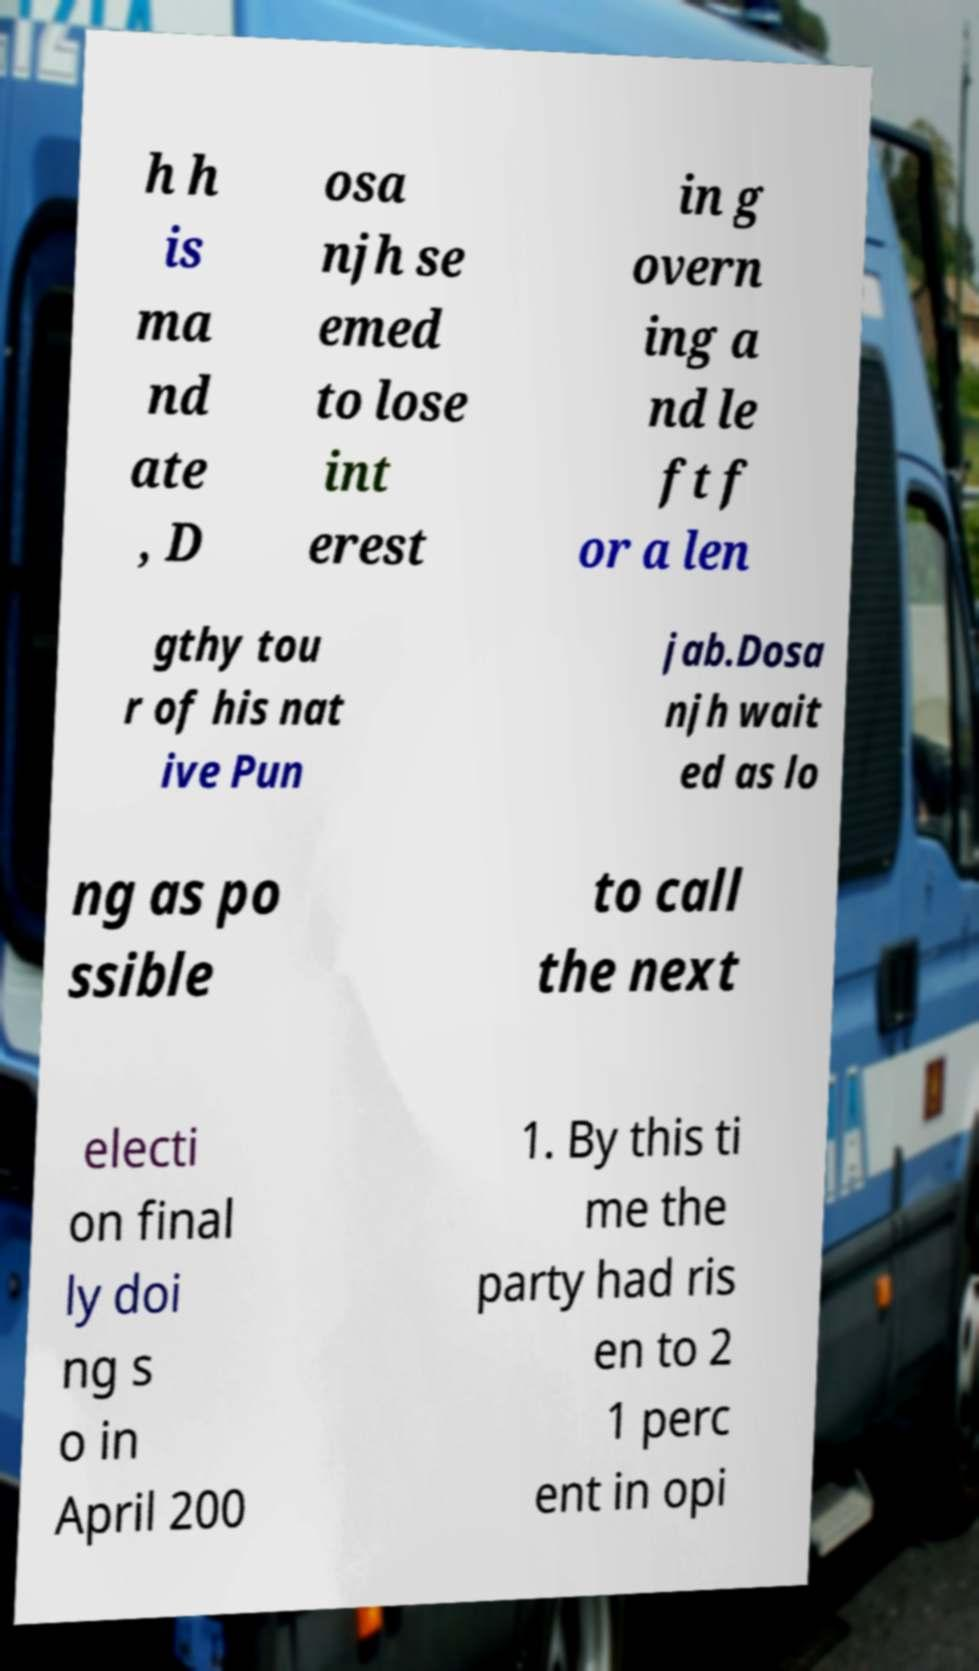Please identify and transcribe the text found in this image. h h is ma nd ate , D osa njh se emed to lose int erest in g overn ing a nd le ft f or a len gthy tou r of his nat ive Pun jab.Dosa njh wait ed as lo ng as po ssible to call the next electi on final ly doi ng s o in April 200 1. By this ti me the party had ris en to 2 1 perc ent in opi 